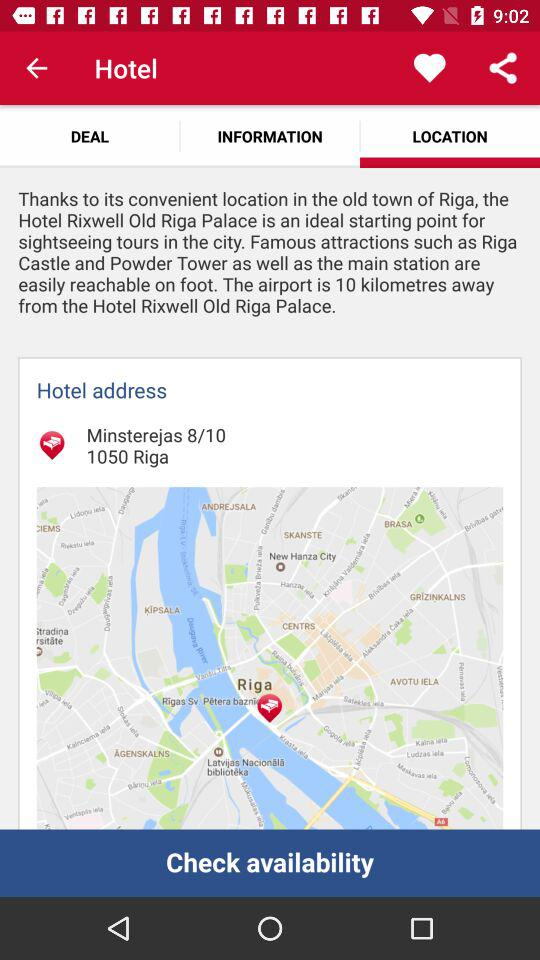What is the hotel's address? The hotel's address is Minsterejas 8/10, 1050 Riga. 